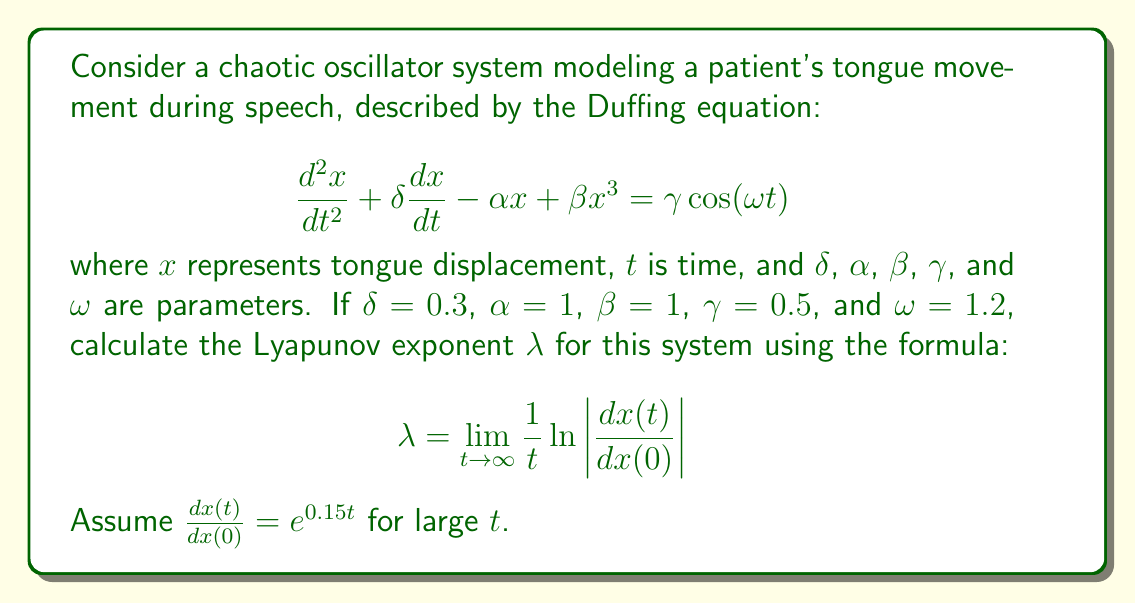Could you help me with this problem? To solve this problem, we'll follow these steps:

1) Recall the formula for the Lyapunov exponent:

   $$\lambda = \lim_{t \to \infty} \frac{1}{t} \ln\left|\frac{dx(t)}{dx(0)}\right|$$

2) We're given that for large $t$, $\frac{dx(t)}{dx(0)} = e^{0.15t}$. Let's substitute this into our formula:

   $$\lambda = \lim_{t \to \infty} \frac{1}{t} \ln\left|e^{0.15t}\right|$$

3) Simplify the absolute value:

   $$\lambda = \lim_{t \to \infty} \frac{1}{t} \ln(e^{0.15t})$$

4) Use the logarithm property $\ln(e^x) = x$:

   $$\lambda = \lim_{t \to \infty} \frac{1}{t} (0.15t)$$

5) Simplify:

   $$\lambda = \lim_{t \to \infty} 0.15$$

6) The limit of a constant is the constant itself, so:

   $$\lambda = 0.15$$

This positive Lyapunov exponent indicates that the system is chaotic, suggesting unpredictable tongue movements that could lead to speech impediments.
Answer: $\lambda = 0.15$ 